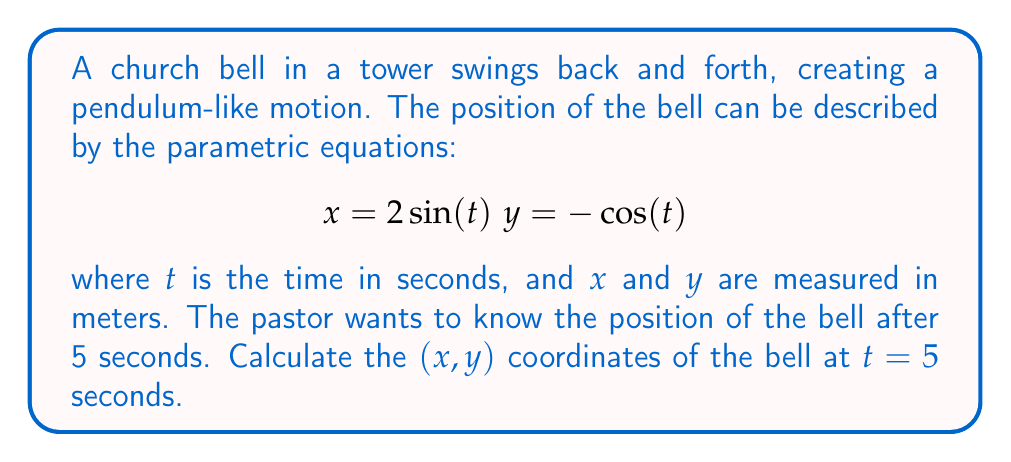Could you help me with this problem? To solve this problem, we need to follow these steps:

1) We have two parametric equations:
   $$x = 2\sin(t)$$
   $$y = -\cos(t)$$

2) We need to find the values of $x$ and $y$ when $t = 5$ seconds.

3) For $x$:
   $$x = 2\sin(5)$$
   Using a calculator or trigonometric tables:
   $$x \approx 2 * (-0.9589) \approx -1.9178$$

4) For $y$:
   $$y = -\cos(5)$$
   Using a calculator or trigonometric tables:
   $$y \approx -1 * (0.2837) \approx -0.2837$$

5) Therefore, the position of the bell after 5 seconds is approximately:
   $$(-1.9178, -0.2837)$$

This point represents the bell's position in a 2D plane, where the origin (0,0) might represent the bell's rest position or the center of its swing.
Answer: The position of the bell after 5 seconds is approximately $(-1.9178, -0.2837)$ meters. 